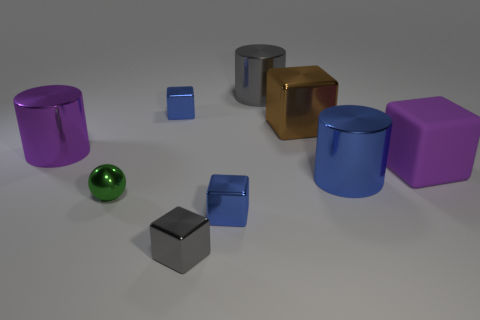Is there anything else that is made of the same material as the big purple block?
Ensure brevity in your answer.  No. What is the material of the blue object that is both to the left of the blue cylinder and behind the tiny metal sphere?
Offer a terse response. Metal. What number of big gray shiny objects are the same shape as the large brown thing?
Keep it short and to the point. 0. What is the size of the purple thing right of the large purple object that is on the left side of the small blue metallic thing that is to the right of the gray block?
Give a very brief answer. Large. Is the number of big blue cylinders that are to the right of the large matte thing greater than the number of big gray objects?
Provide a succinct answer. No. Are there any rubber blocks?
Provide a succinct answer. Yes. What number of blue shiny cubes have the same size as the sphere?
Offer a very short reply. 2. Are there more cylinders behind the blue shiny cylinder than gray metal cylinders in front of the sphere?
Provide a short and direct response. Yes. There is a brown cube that is the same size as the blue metallic cylinder; what material is it?
Provide a short and direct response. Metal. What is the shape of the purple shiny thing?
Your answer should be compact. Cylinder. 